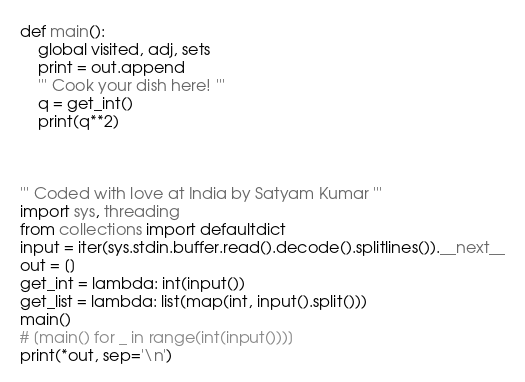Convert code to text. <code><loc_0><loc_0><loc_500><loc_500><_Python_>def main():
    global visited, adj, sets
    print = out.append
    ''' Cook your dish here! '''
    q = get_int()
    print(q**2)



''' Coded with love at India by Satyam Kumar '''
import sys, threading
from collections import defaultdict
input = iter(sys.stdin.buffer.read().decode().splitlines()).__next__
out = []
get_int = lambda: int(input())
get_list = lambda: list(map(int, input().split()))
main()
# [main() for _ in range(int(input()))]
print(*out, sep='\n')</code> 